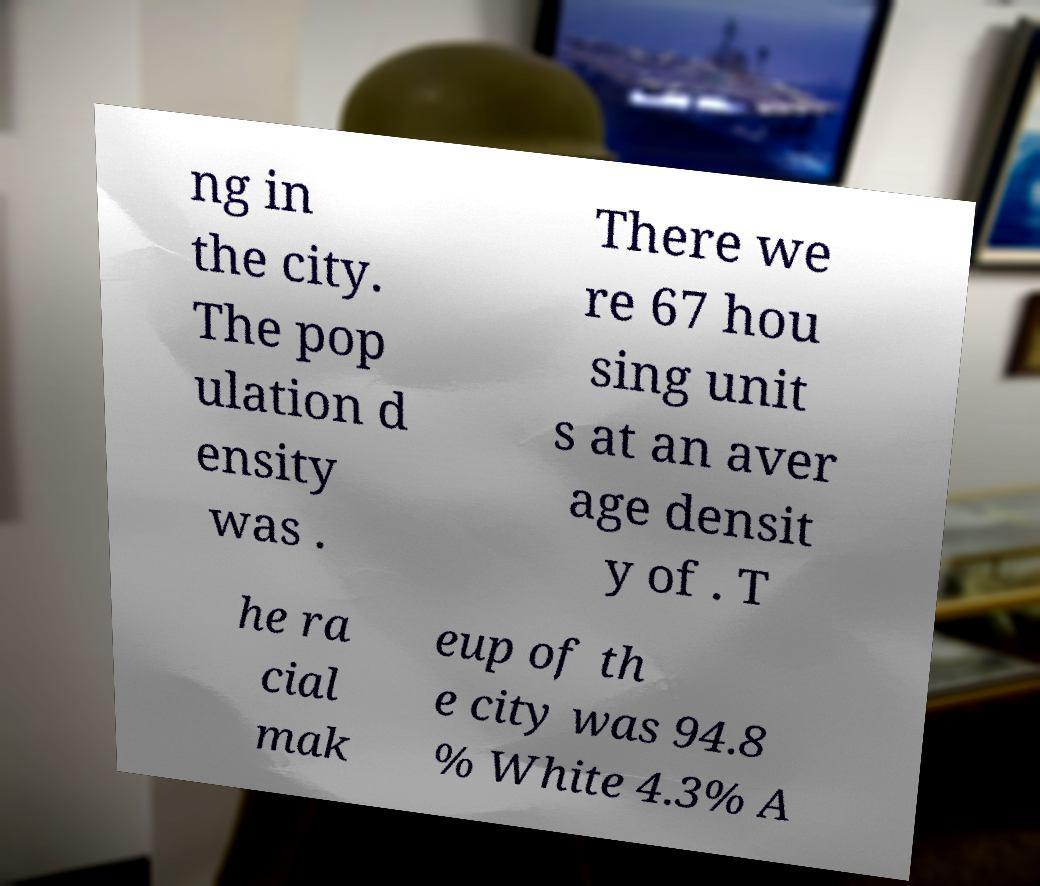Could you extract and type out the text from this image? ng in the city. The pop ulation d ensity was . There we re 67 hou sing unit s at an aver age densit y of . T he ra cial mak eup of th e city was 94.8 % White 4.3% A 